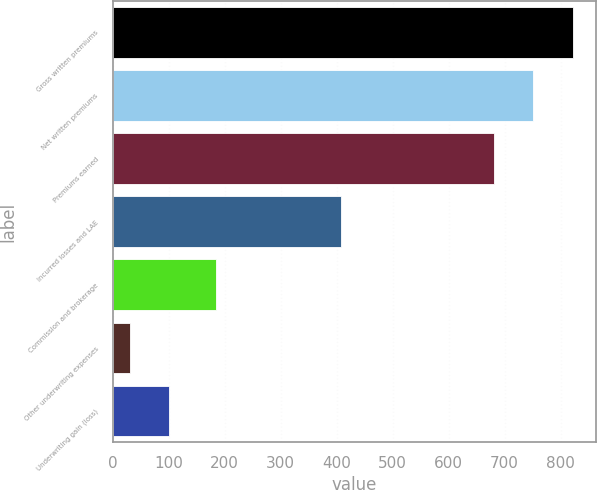Convert chart to OTSL. <chart><loc_0><loc_0><loc_500><loc_500><bar_chart><fcel>Gross written premiums<fcel>Net written premiums<fcel>Premiums earned<fcel>Incurred losses and LAE<fcel>Commission and brokerage<fcel>Other underwriting expenses<fcel>Underwriting gain (loss)<nl><fcel>821.66<fcel>751.28<fcel>680.9<fcel>408.2<fcel>184.4<fcel>30.6<fcel>100.98<nl></chart> 